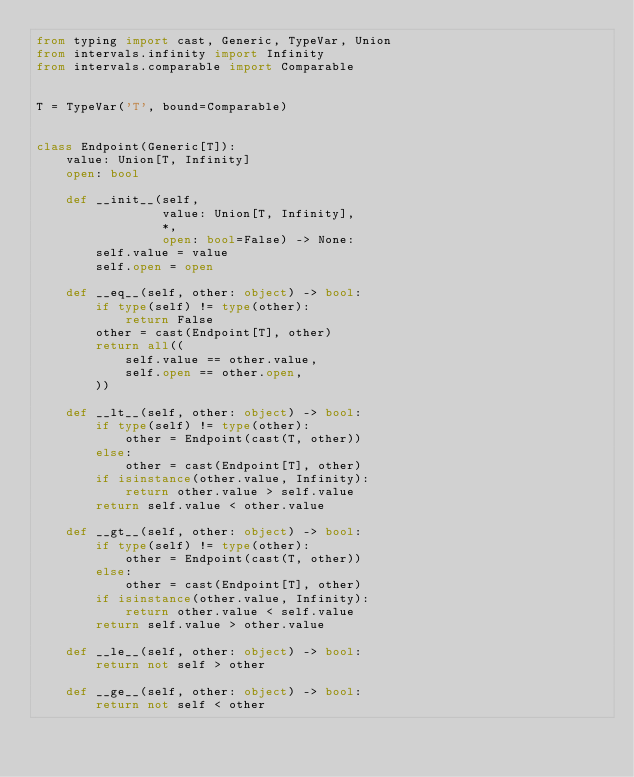Convert code to text. <code><loc_0><loc_0><loc_500><loc_500><_Python_>from typing import cast, Generic, TypeVar, Union
from intervals.infinity import Infinity
from intervals.comparable import Comparable


T = TypeVar('T', bound=Comparable)


class Endpoint(Generic[T]):
    value: Union[T, Infinity]
    open: bool

    def __init__(self,
                 value: Union[T, Infinity],
                 *,
                 open: bool=False) -> None:
        self.value = value
        self.open = open

    def __eq__(self, other: object) -> bool:
        if type(self) != type(other):
            return False
        other = cast(Endpoint[T], other)
        return all((
            self.value == other.value,
            self.open == other.open,
        ))

    def __lt__(self, other: object) -> bool:
        if type(self) != type(other):
            other = Endpoint(cast(T, other))
        else:
            other = cast(Endpoint[T], other)
        if isinstance(other.value, Infinity):
            return other.value > self.value
        return self.value < other.value

    def __gt__(self, other: object) -> bool:
        if type(self) != type(other):
            other = Endpoint(cast(T, other))
        else:
            other = cast(Endpoint[T], other)
        if isinstance(other.value, Infinity):
            return other.value < self.value
        return self.value > other.value

    def __le__(self, other: object) -> bool:
        return not self > other

    def __ge__(self, other: object) -> bool:
        return not self < other
</code> 